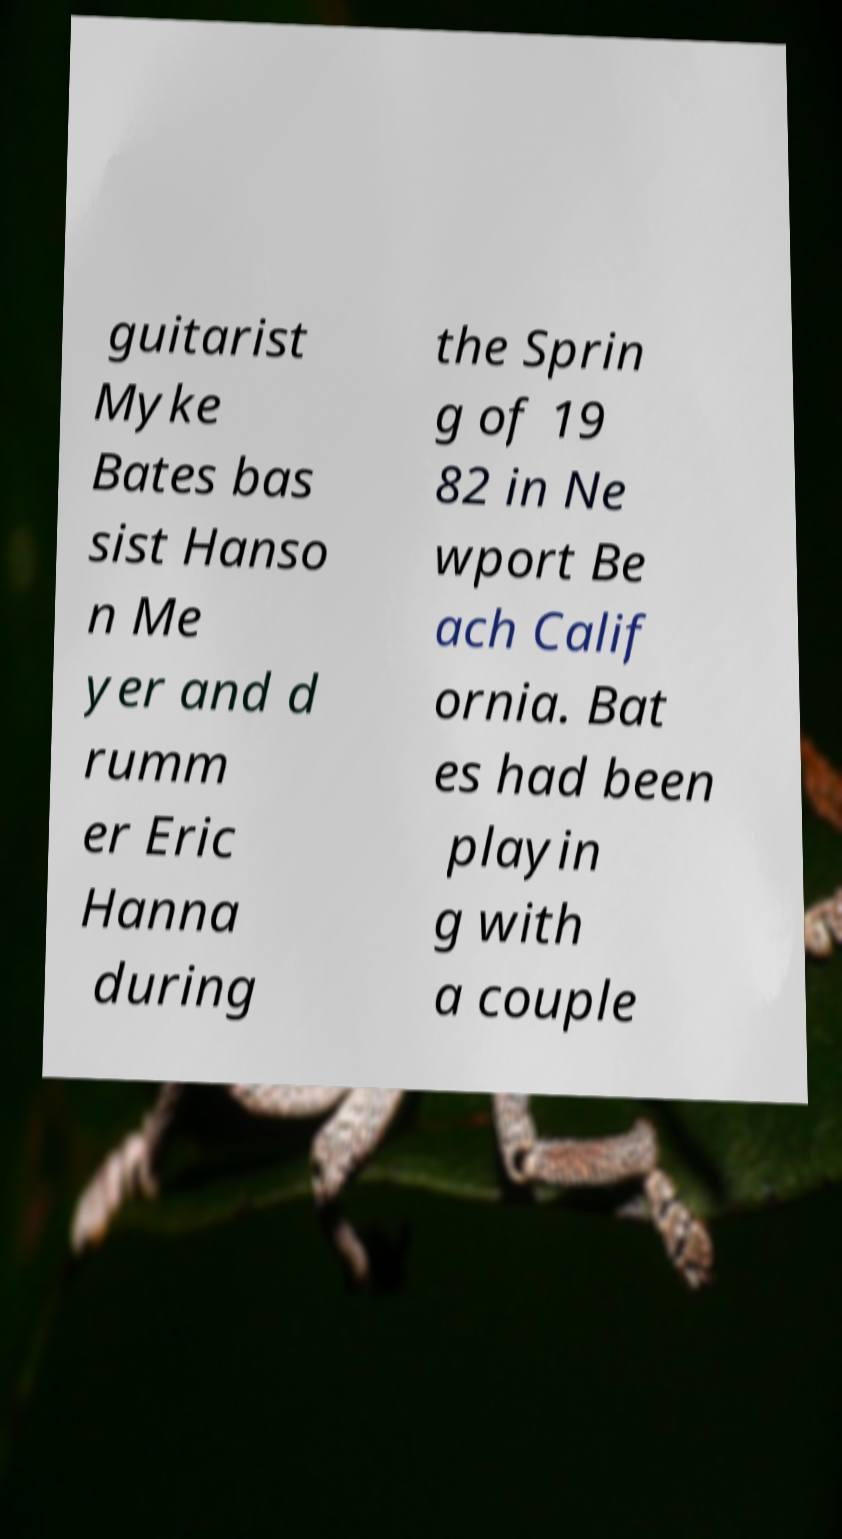What messages or text are displayed in this image? I need them in a readable, typed format. guitarist Myke Bates bas sist Hanso n Me yer and d rumm er Eric Hanna during the Sprin g of 19 82 in Ne wport Be ach Calif ornia. Bat es had been playin g with a couple 